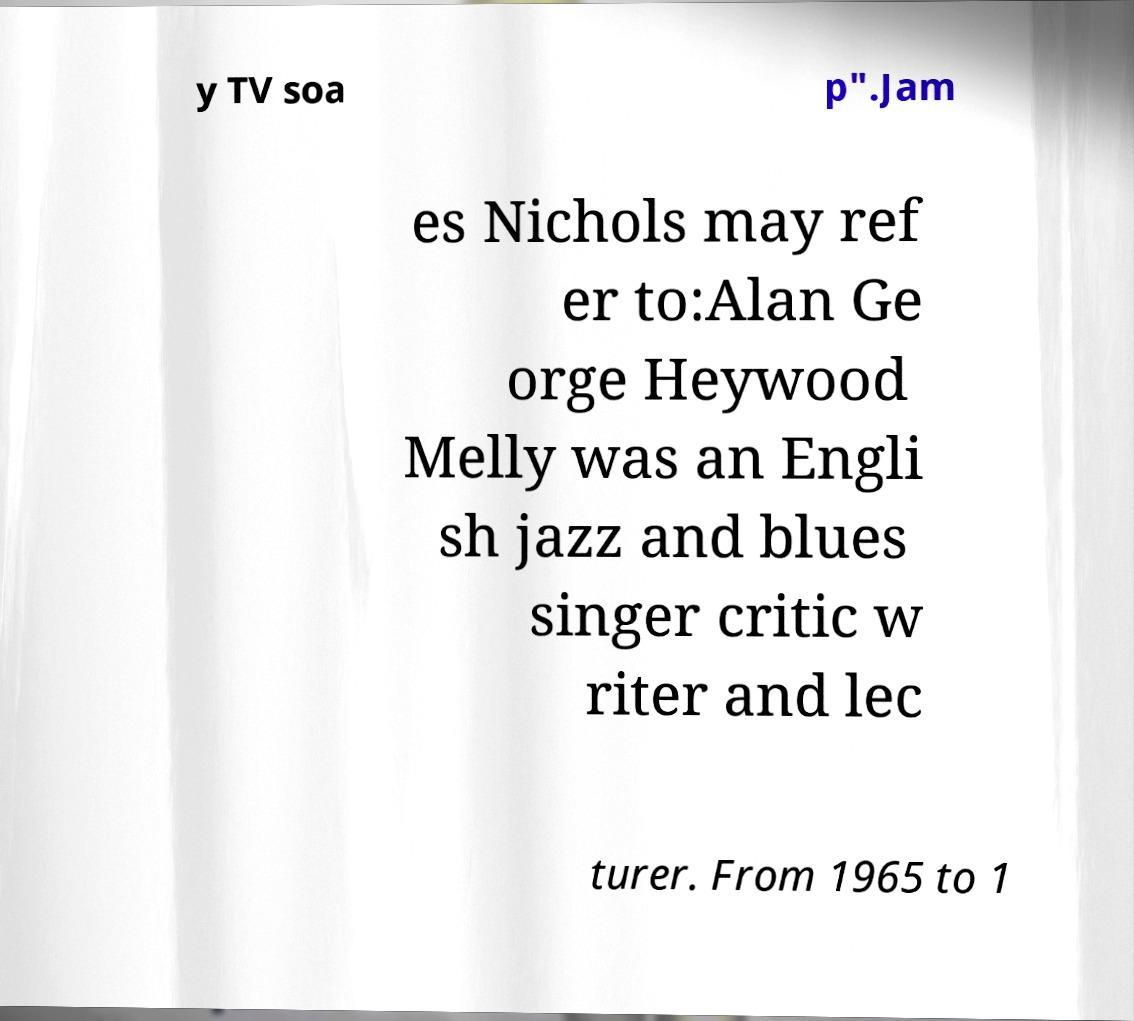I need the written content from this picture converted into text. Can you do that? y TV soa p".Jam es Nichols may ref er to:Alan Ge orge Heywood Melly was an Engli sh jazz and blues singer critic w riter and lec turer. From 1965 to 1 